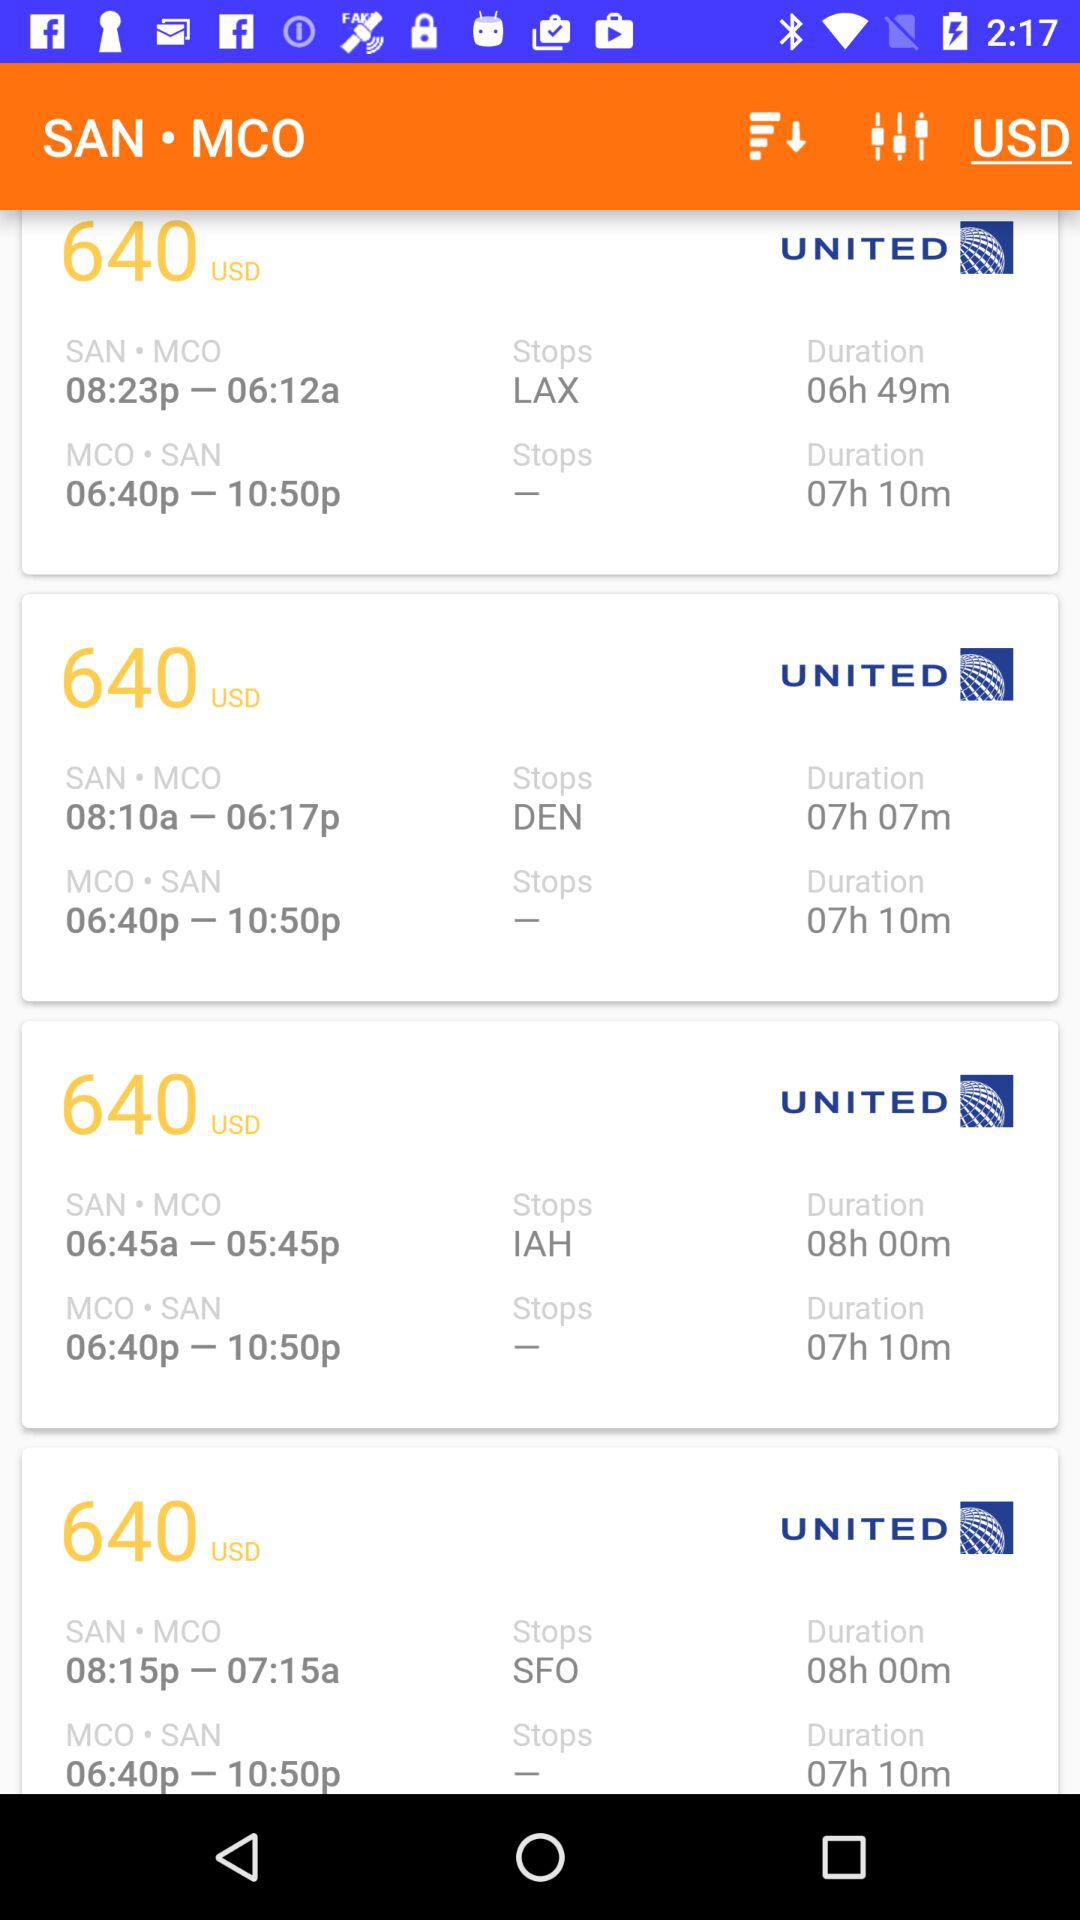What is the given currency? The given currency is United States dollars. 